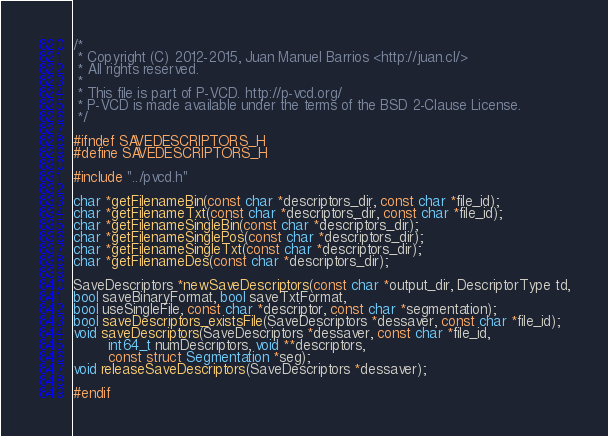Convert code to text. <code><loc_0><loc_0><loc_500><loc_500><_C_>/*
 * Copyright (C) 2012-2015, Juan Manuel Barrios <http://juan.cl/>
 * All rights reserved.
 *
 * This file is part of P-VCD. http://p-vcd.org/
 * P-VCD is made available under the terms of the BSD 2-Clause License.
 */

#ifndef SAVEDESCRIPTORS_H
#define SAVEDESCRIPTORS_H

#include "../pvcd.h"

char *getFilenameBin(const char *descriptors_dir, const char *file_id);
char *getFilenameTxt(const char *descriptors_dir, const char *file_id);
char *getFilenameSingleBin(const char *descriptors_dir);
char *getFilenameSinglePos(const char *descriptors_dir);
char *getFilenameSingleTxt(const char *descriptors_dir);
char *getFilenameDes(const char *descriptors_dir);

SaveDescriptors *newSaveDescriptors(const char *output_dir, DescriptorType td,
bool saveBinaryFormat, bool saveTxtFormat,
bool useSingleFile, const char *descriptor, const char *segmentation);
bool saveDescriptors_existsFile(SaveDescriptors *dessaver, const char *file_id);
void saveDescriptors(SaveDescriptors *dessaver, const char *file_id,
		int64_t numDescriptors, void **descriptors,
		const struct Segmentation *seg);
void releaseSaveDescriptors(SaveDescriptors *dessaver);

#endif
</code> 